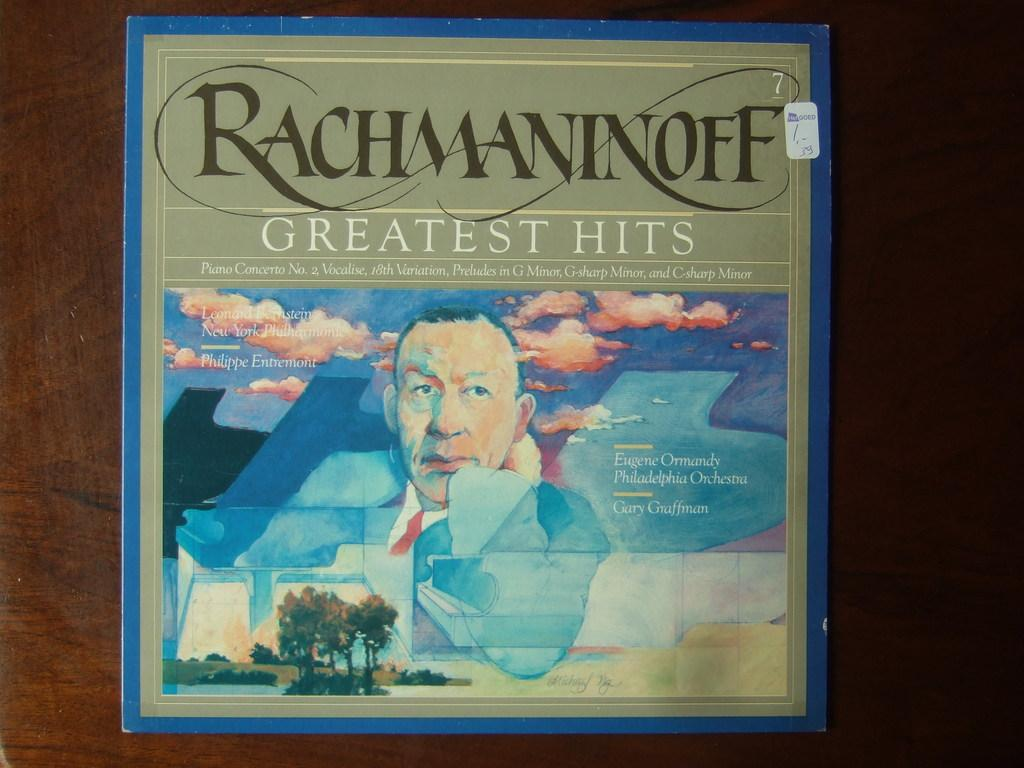<image>
Describe the image concisely. A Rachmaninoff LP cover for his Greatest Hits collection. 